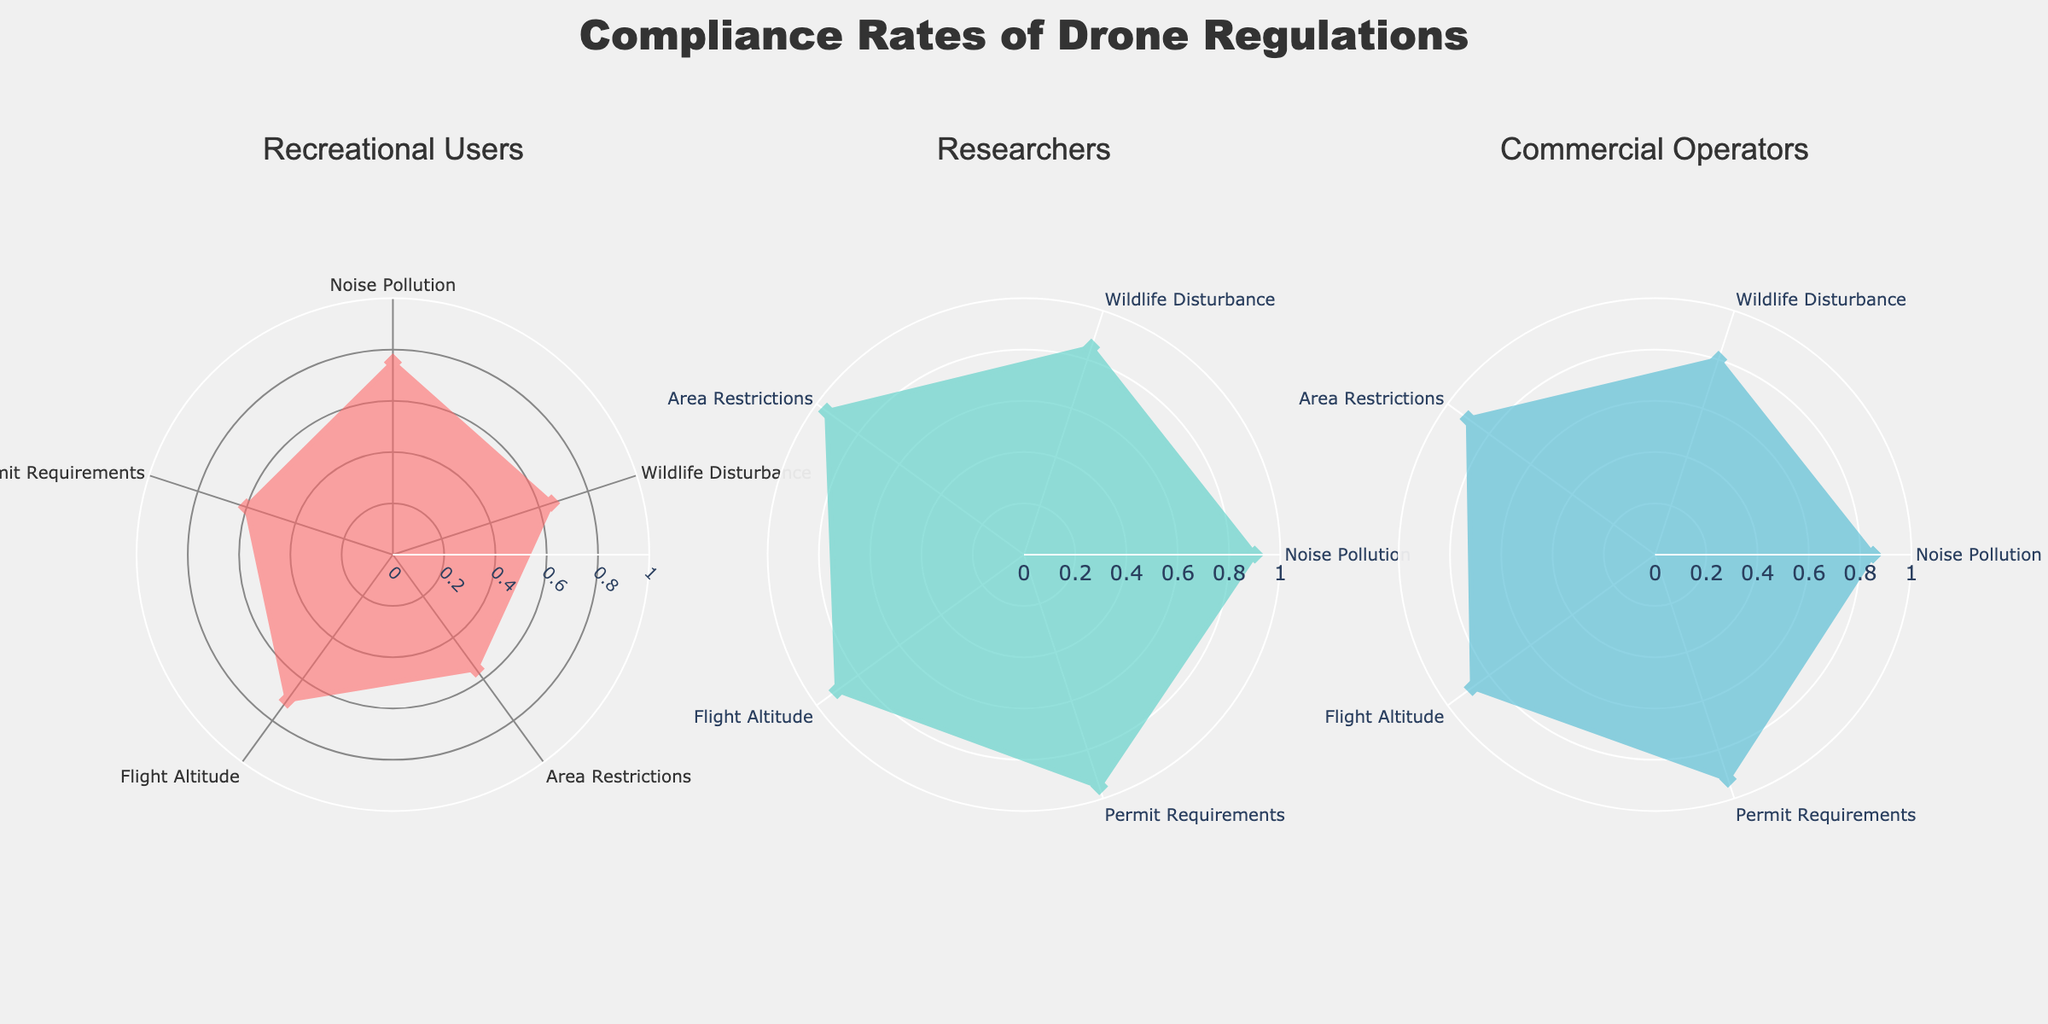What's the title of the figure? The title is typically located at the top center of the chart. It provides context on what the figure is about.
Answer: Compliance Rates of Drone Regulations Which entity has the lowest compliance rate for Area Restrictions? To find the lowest compliance rate for Area Restrictions, compare the values for Recreational Users, Researchers, and Commercial Operators in that category.
Answer: Recreational Users What are the compliance rates for Researchers across all categories? Locate the radar chart for Researchers and read the values corresponding to each category: Noise Pollution, Wildlife Disturbance, Area Restrictions, Flight Altitude, and Permit Requirements.
Answer: 0.90, 0.85, 0.95, 0.90, 0.95 Which category has the highest compliance rate for Recreational Users? Look at the radar chart for Recreational Users and identify the category with the highest value.
Answer: Noise Pollution What's the average compliance rate for Commercial Operators in Noise Pollution and Flight Altitude? Extract the values for Noise Pollution (0.85) and Flight Altitude (0.88) for Commercial Operators and calculate the average: (0.85 + 0.88) / 2 = 0.865.
Answer: 0.865 How do the compliance rates for Permit Requirements compare among the three entities? Compare the compliance rates under the Permit Requirements category for Recreational Users (0.60), Researchers (0.95), and Commercial Operators (0.92).
Answer: Recreational Users < Commercial Operators < Researchers Which entity has the most uniform compliance rates across all categories? Uniformity can be observed by looking at how much each plot deviates from being a perfect circle. Compare the shapes of the radar charts for Recreational Users, Researchers, and Commercial Operators.
Answer: Researchers What is the total compliance score for Recreational Users across all categories? Add up the compliance rates for Recreational Users: 0.75 (Noise Pollution) + 0.65 (Wildlife Disturbance) + 0.55 (Area Restrictions) + 0.70 (Flight Altitude) + 0.60 (Permit Requirements) = 3.25.
Answer: 3.25 What is the median compliance rate for Commercial Operators? The compliance rates for Commercial Operators are 0.85 (Noise Pollution), 0.80 (Wildlife Disturbance), 0.90 (Area Restrictions), 0.88 (Flight Altitude), and 0.92 (Permit Requirements). Arrange these values in ascending order: 0.80, 0.85, 0.88, 0.90, 0.92. The median value is the middle one: 0.88.
Answer: 0.88 